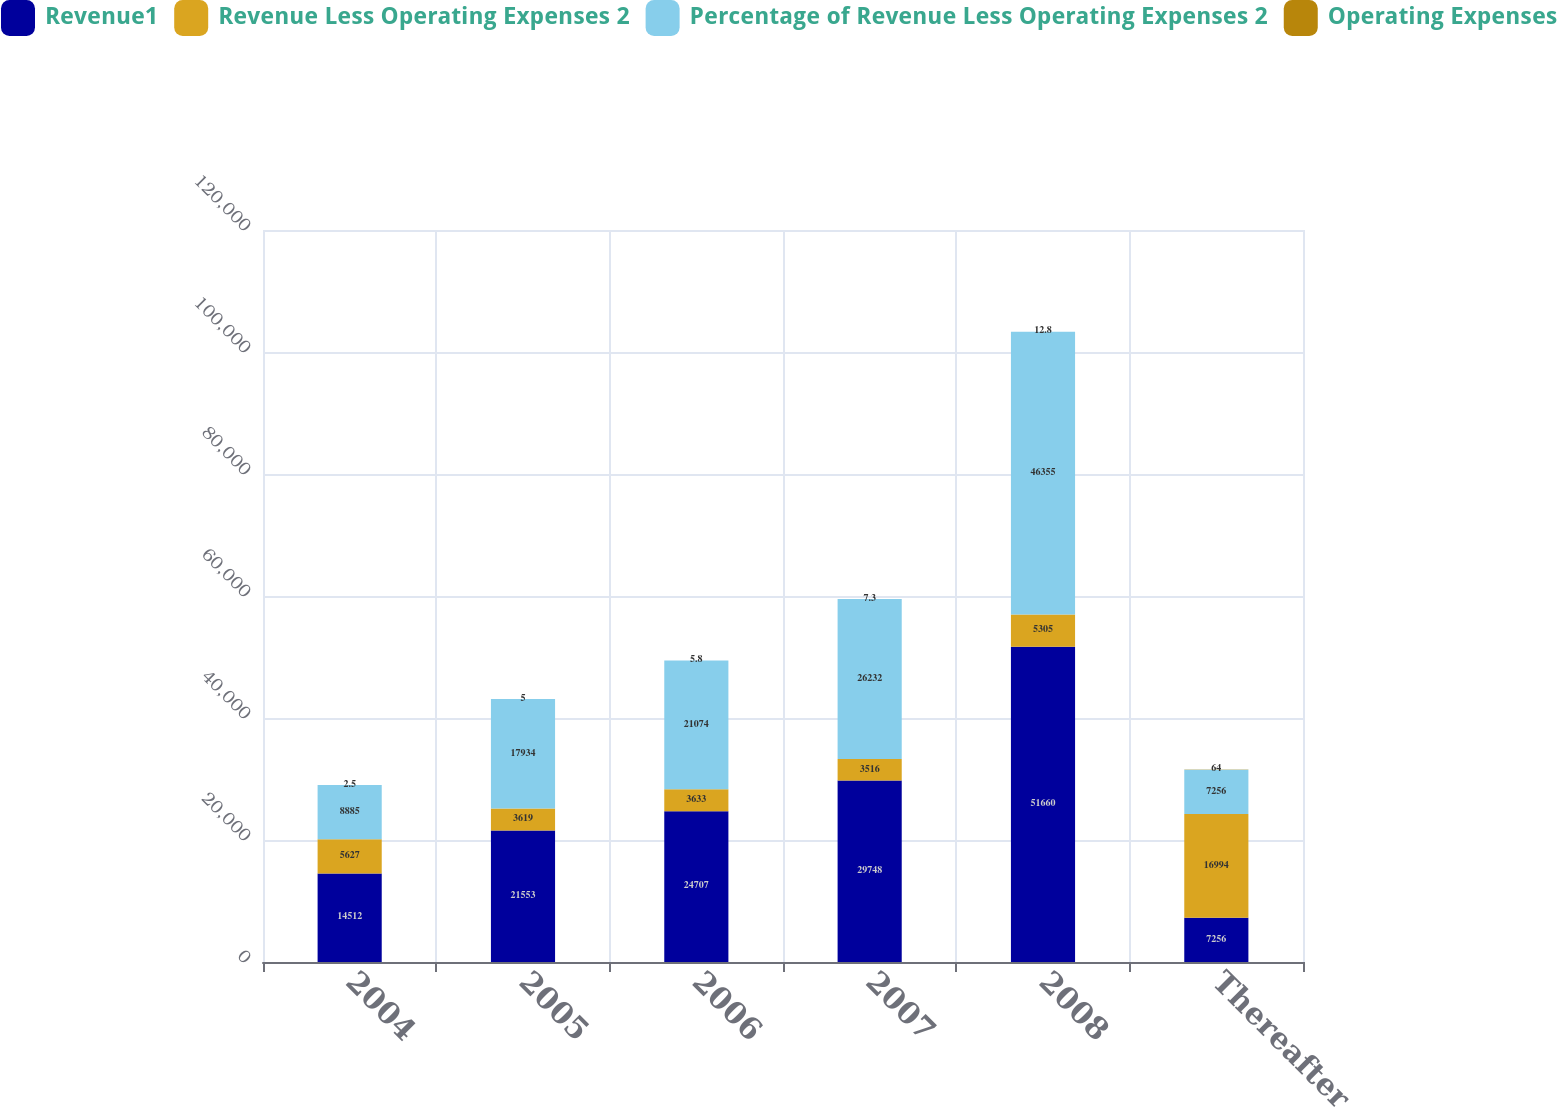Convert chart to OTSL. <chart><loc_0><loc_0><loc_500><loc_500><stacked_bar_chart><ecel><fcel>2004<fcel>2005<fcel>2006<fcel>2007<fcel>2008<fcel>Thereafter<nl><fcel>Revenue1<fcel>14512<fcel>21553<fcel>24707<fcel>29748<fcel>51660<fcel>7256<nl><fcel>Revenue Less Operating Expenses 2<fcel>5627<fcel>3619<fcel>3633<fcel>3516<fcel>5305<fcel>16994<nl><fcel>Percentage of Revenue Less Operating Expenses 2<fcel>8885<fcel>17934<fcel>21074<fcel>26232<fcel>46355<fcel>7256<nl><fcel>Operating Expenses<fcel>2.5<fcel>5<fcel>5.8<fcel>7.3<fcel>12.8<fcel>64<nl></chart> 